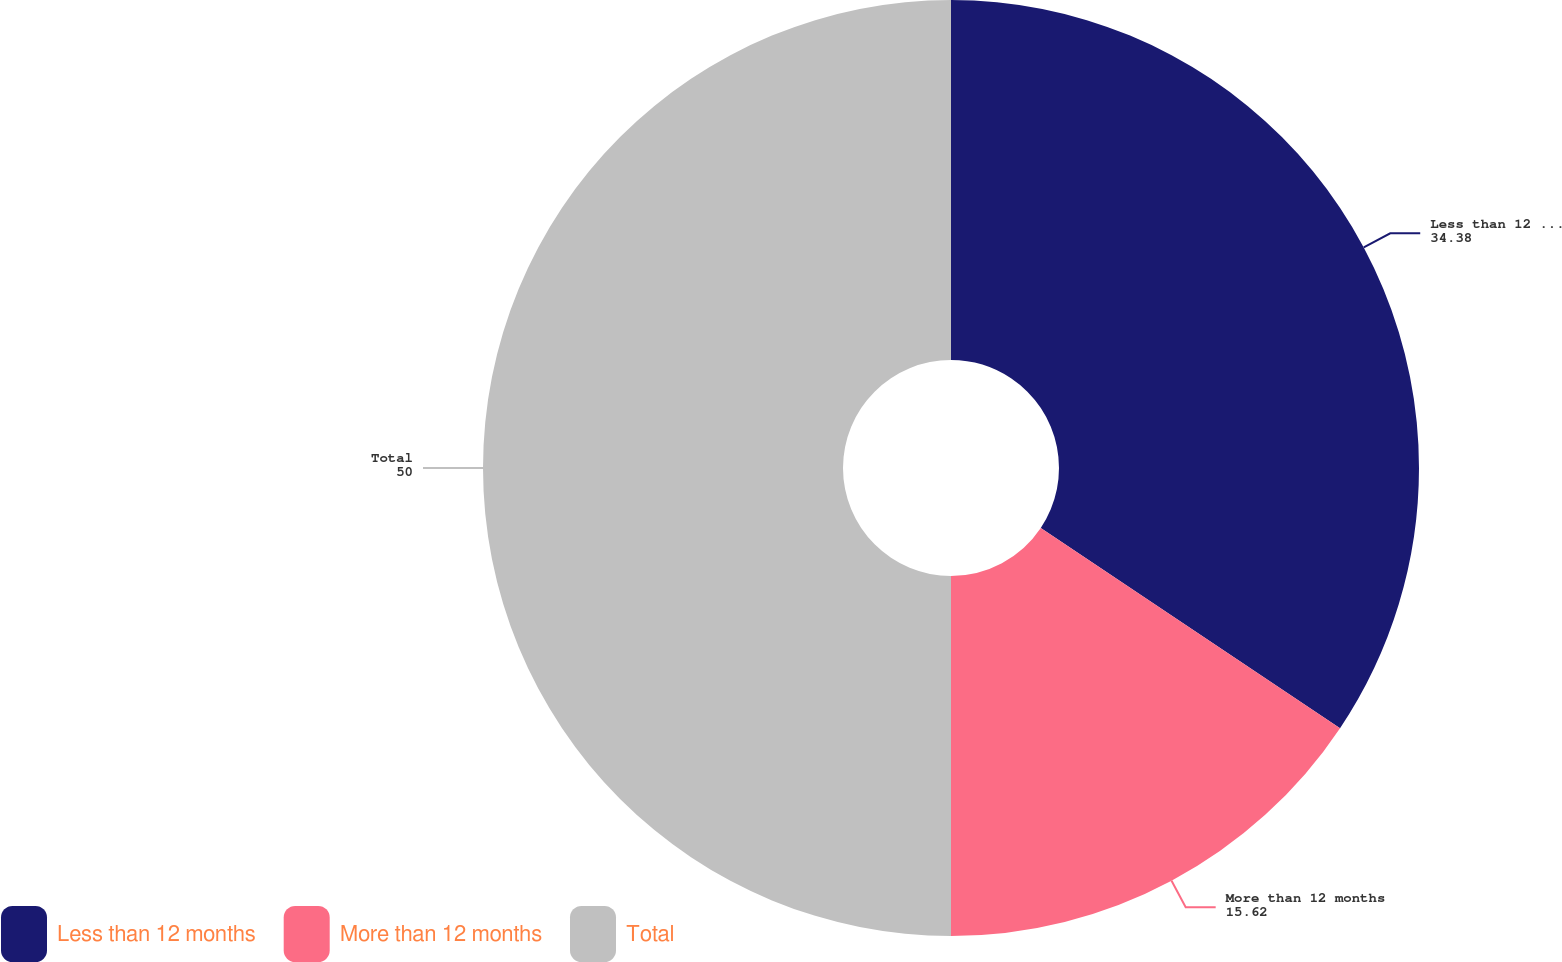<chart> <loc_0><loc_0><loc_500><loc_500><pie_chart><fcel>Less than 12 months<fcel>More than 12 months<fcel>Total<nl><fcel>34.38%<fcel>15.62%<fcel>50.0%<nl></chart> 